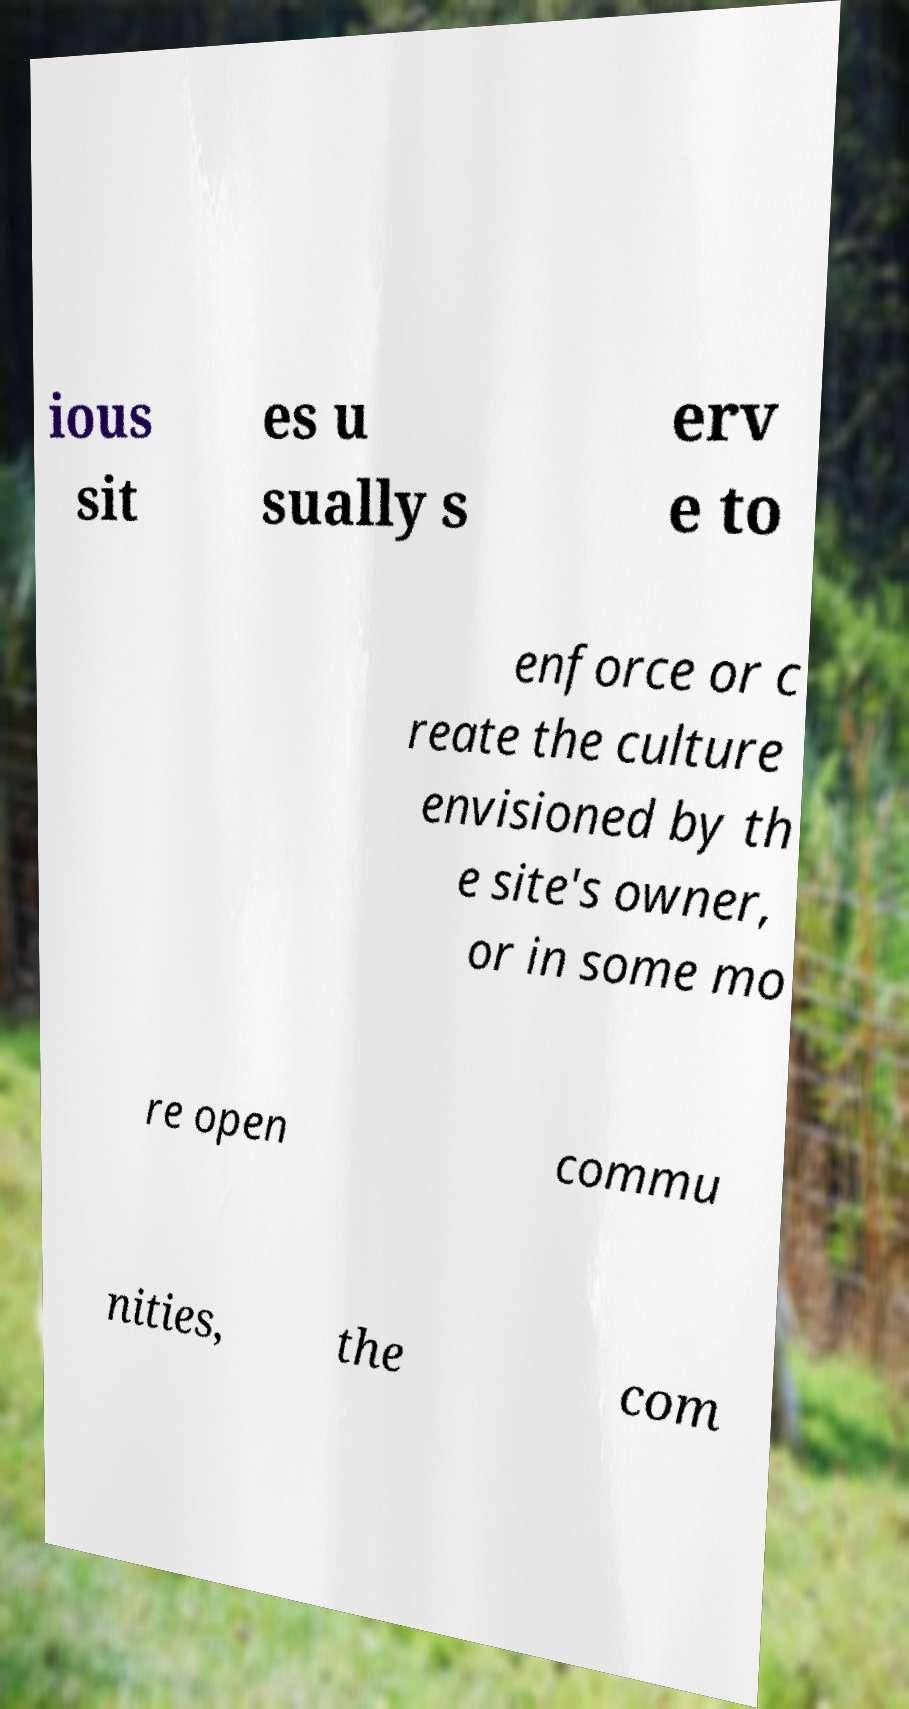For documentation purposes, I need the text within this image transcribed. Could you provide that? ious sit es u sually s erv e to enforce or c reate the culture envisioned by th e site's owner, or in some mo re open commu nities, the com 